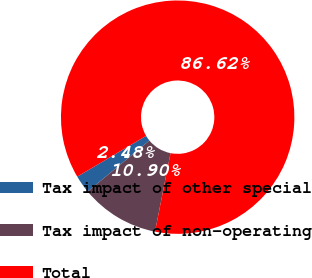Convert chart to OTSL. <chart><loc_0><loc_0><loc_500><loc_500><pie_chart><fcel>Tax impact of other special<fcel>Tax impact of non-operating<fcel>Total<nl><fcel>2.48%<fcel>10.9%<fcel>86.62%<nl></chart> 